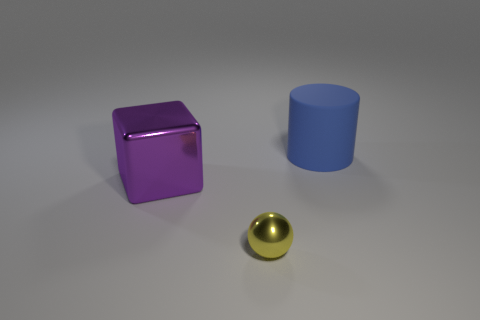Add 1 tiny red rubber blocks. How many objects exist? 4 Subtract all blocks. How many objects are left? 2 Subtract 1 yellow balls. How many objects are left? 2 Subtract all large shiny things. Subtract all small yellow metallic objects. How many objects are left? 1 Add 3 big rubber cylinders. How many big rubber cylinders are left? 4 Add 1 small yellow balls. How many small yellow balls exist? 2 